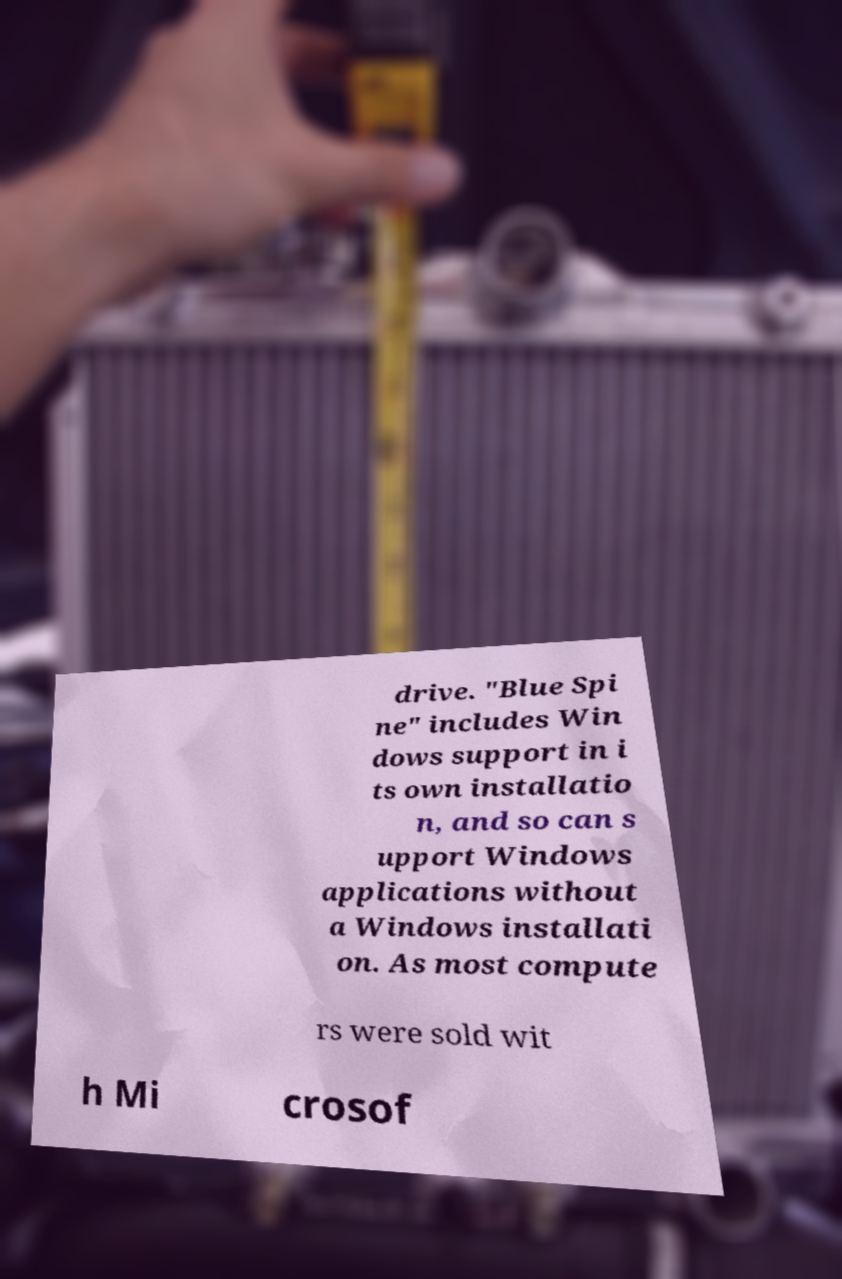There's text embedded in this image that I need extracted. Can you transcribe it verbatim? drive. "Blue Spi ne" includes Win dows support in i ts own installatio n, and so can s upport Windows applications without a Windows installati on. As most compute rs were sold wit h Mi crosof 